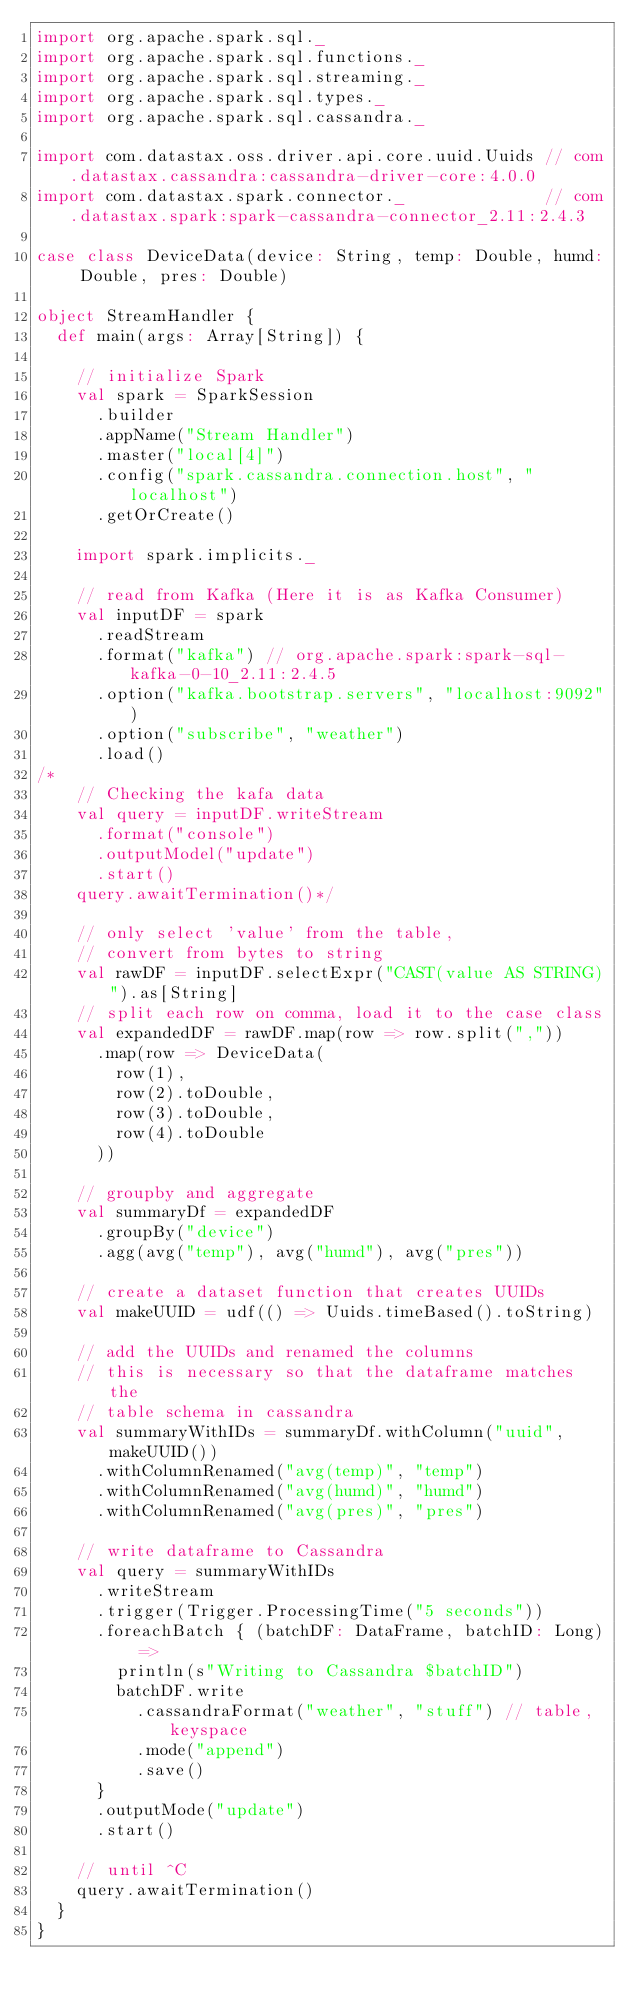Convert code to text. <code><loc_0><loc_0><loc_500><loc_500><_Scala_>import org.apache.spark.sql._
import org.apache.spark.sql.functions._
import org.apache.spark.sql.streaming._
import org.apache.spark.sql.types._
import org.apache.spark.sql.cassandra._

import com.datastax.oss.driver.api.core.uuid.Uuids // com.datastax.cassandra:cassandra-driver-core:4.0.0
import com.datastax.spark.connector._              // com.datastax.spark:spark-cassandra-connector_2.11:2.4.3

case class DeviceData(device: String, temp: Double, humd: Double, pres: Double)

object StreamHandler {
	def main(args: Array[String]) {

		// initialize Spark
		val spark = SparkSession
			.builder
			.appName("Stream Handler")
		  .master("local[4]")
			.config("spark.cassandra.connection.host", "localhost")
			.getOrCreate()

		import spark.implicits._

		// read from Kafka (Here it is as Kafka Consumer)
		val inputDF = spark
			.readStream
			.format("kafka") // org.apache.spark:spark-sql-kafka-0-10_2.11:2.4.5
			.option("kafka.bootstrap.servers", "localhost:9092")
			.option("subscribe", "weather")
			.load()
/*
		// Checking the kafa data
		val query = inputDF.writeStream
		  .format("console")
		  .outputModel("update")
		  .start()
		query.awaitTermination()*/

		// only select 'value' from the table,
		// convert from bytes to string
		val rawDF = inputDF.selectExpr("CAST(value AS STRING)").as[String]
		// split each row on comma, load it to the case class
		val expandedDF = rawDF.map(row => row.split(","))
			.map(row => DeviceData(
				row(1),
				row(2).toDouble,
				row(3).toDouble,
				row(4).toDouble
			))

		// groupby and aggregate
		val summaryDf = expandedDF
			.groupBy("device")
			.agg(avg("temp"), avg("humd"), avg("pres"))

		// create a dataset function that creates UUIDs
		val makeUUID = udf(() => Uuids.timeBased().toString)

		// add the UUIDs and renamed the columns
		// this is necessary so that the dataframe matches the 
		// table schema in cassandra
		val summaryWithIDs = summaryDf.withColumn("uuid", makeUUID())
			.withColumnRenamed("avg(temp)", "temp")
			.withColumnRenamed("avg(humd)", "humd")
			.withColumnRenamed("avg(pres)", "pres")

		// write dataframe to Cassandra
		val query = summaryWithIDs
			.writeStream
			.trigger(Trigger.ProcessingTime("5 seconds"))
			.foreachBatch { (batchDF: DataFrame, batchID: Long) =>
				println(s"Writing to Cassandra $batchID")
				batchDF.write
					.cassandraFormat("weather", "stuff") // table, keyspace
					.mode("append")
					.save()
			}
			.outputMode("update")
			.start()

		// until ^C
		query.awaitTermination()
	}
}</code> 